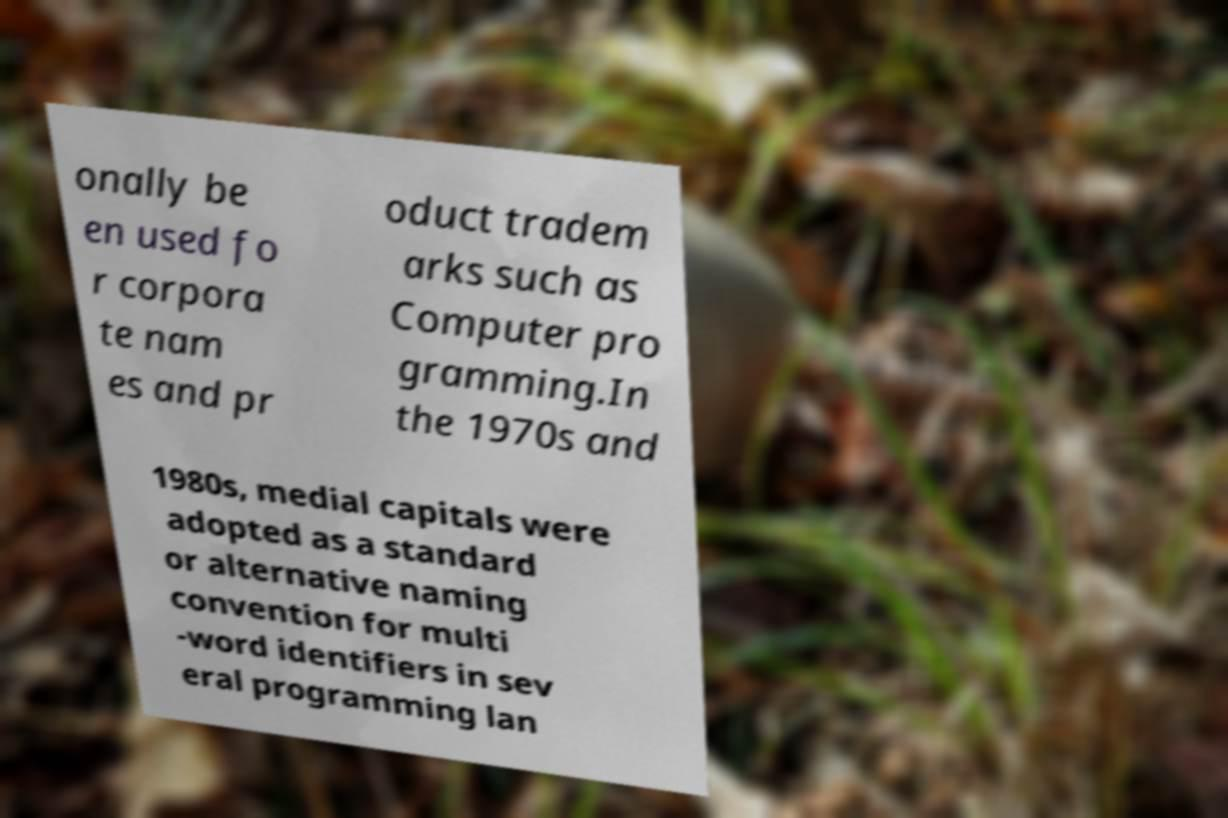Can you read and provide the text displayed in the image?This photo seems to have some interesting text. Can you extract and type it out for me? onally be en used fo r corpora te nam es and pr oduct tradem arks such as Computer pro gramming.In the 1970s and 1980s, medial capitals were adopted as a standard or alternative naming convention for multi -word identifiers in sev eral programming lan 